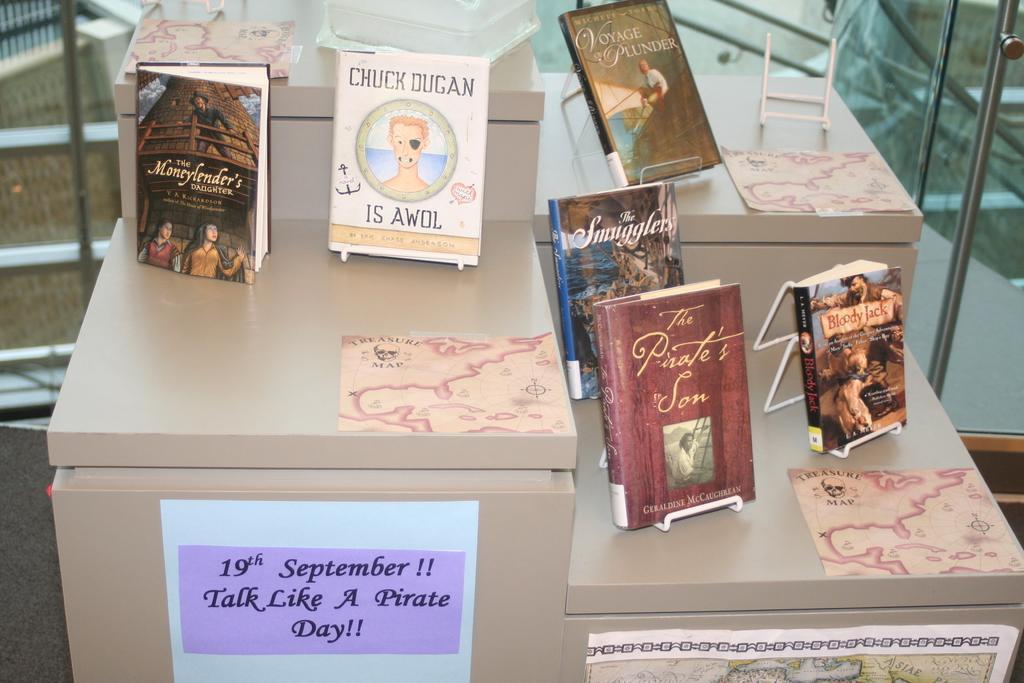How would you summarize this image in a sentence or two? In this image there is an object looks like a table, on top of it there are books with some text are arranged and some papers are attached, behind that there are stairs. 